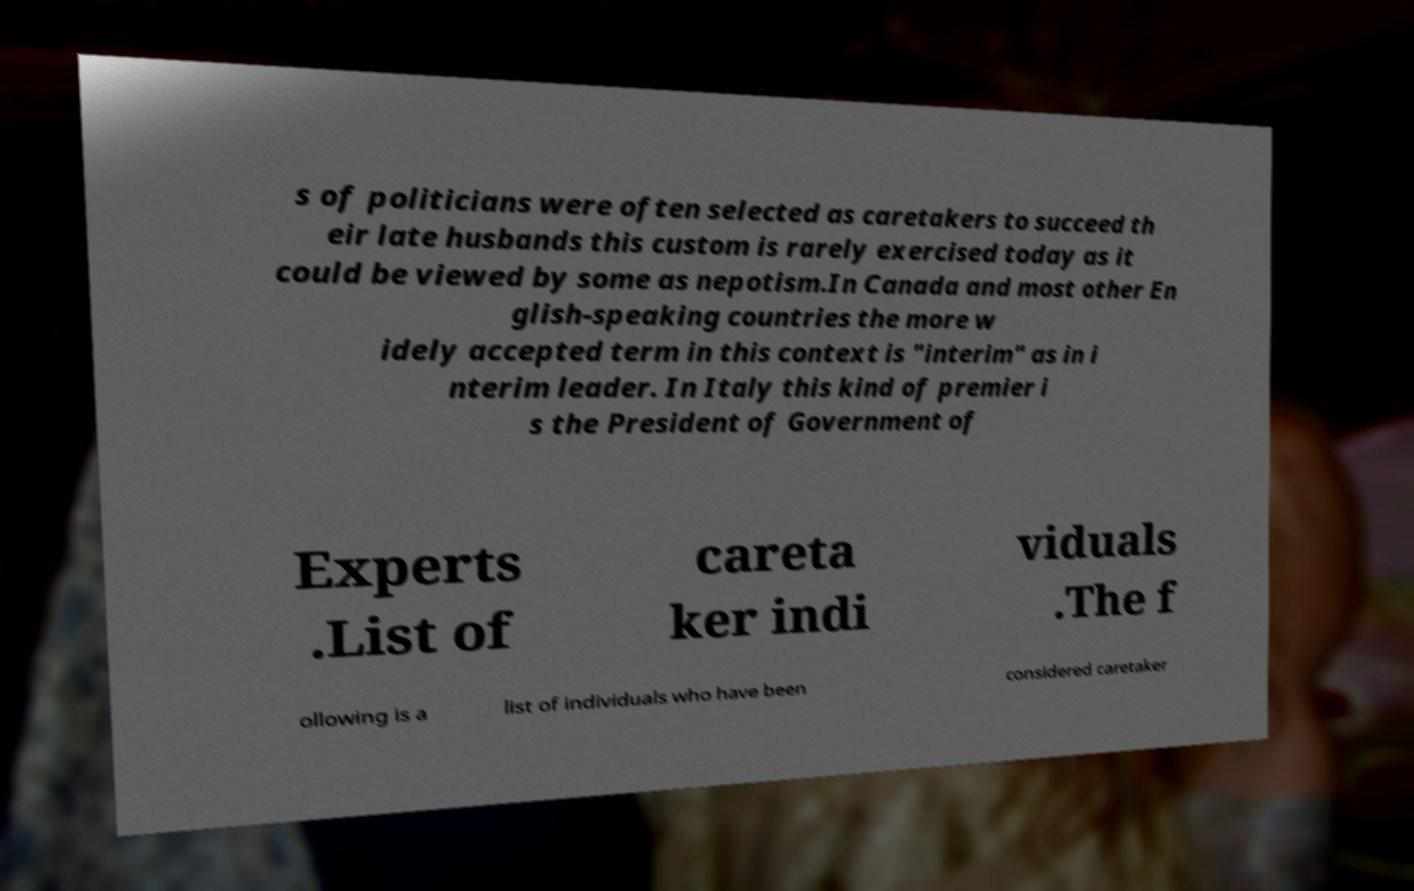There's text embedded in this image that I need extracted. Can you transcribe it verbatim? s of politicians were often selected as caretakers to succeed th eir late husbands this custom is rarely exercised today as it could be viewed by some as nepotism.In Canada and most other En glish-speaking countries the more w idely accepted term in this context is "interim" as in i nterim leader. In Italy this kind of premier i s the President of Government of Experts .List of careta ker indi viduals .The f ollowing is a list of individuals who have been considered caretaker 